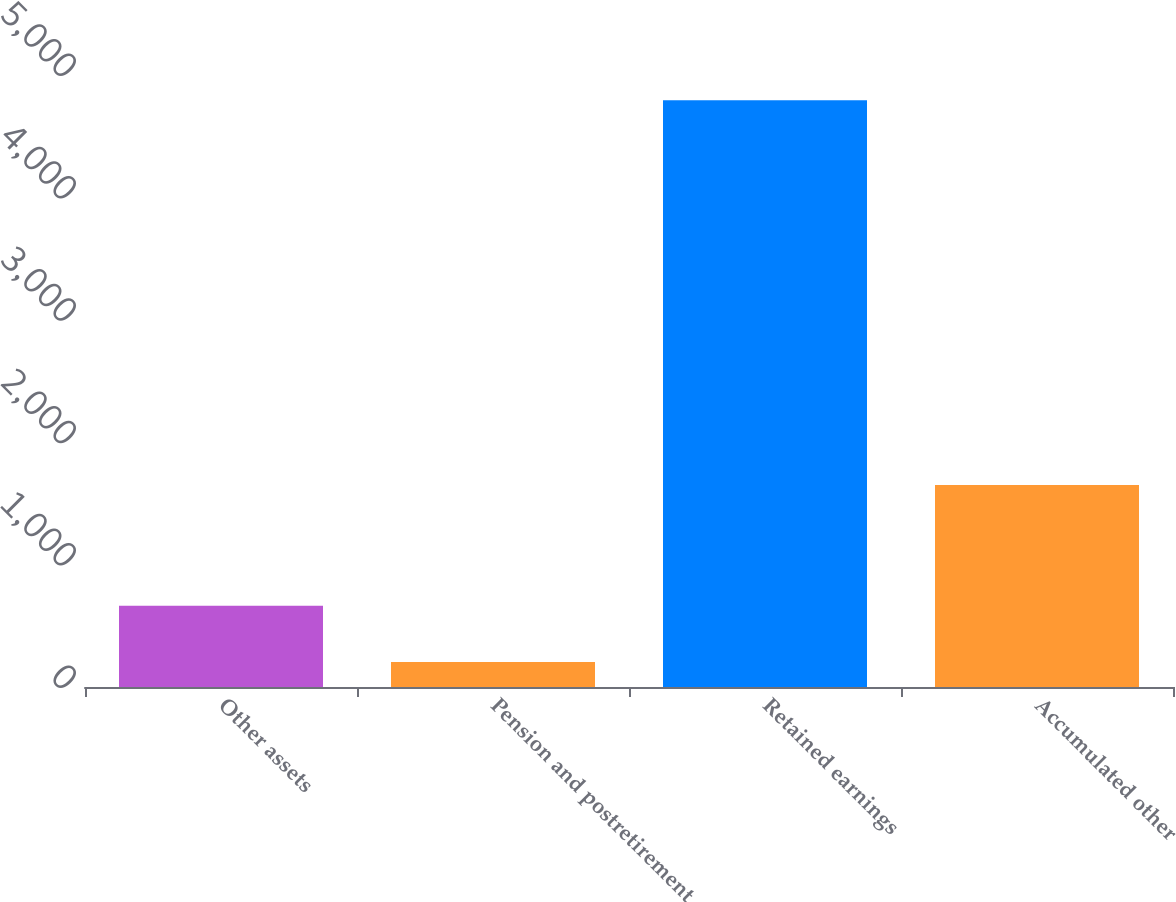Convert chart to OTSL. <chart><loc_0><loc_0><loc_500><loc_500><bar_chart><fcel>Other assets<fcel>Pension and postretirement<fcel>Retained earnings<fcel>Accumulated other<nl><fcel>663.21<fcel>204.2<fcel>4794.3<fcel>1650.9<nl></chart> 